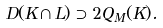<formula> <loc_0><loc_0><loc_500><loc_500>D ( K \cap L ) \supset 2 Q _ { M } ( K ) .</formula> 